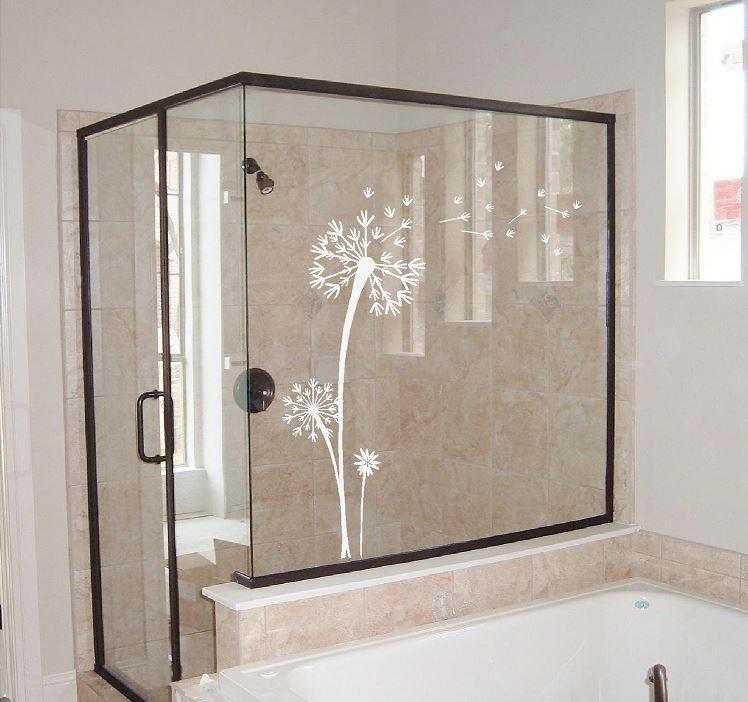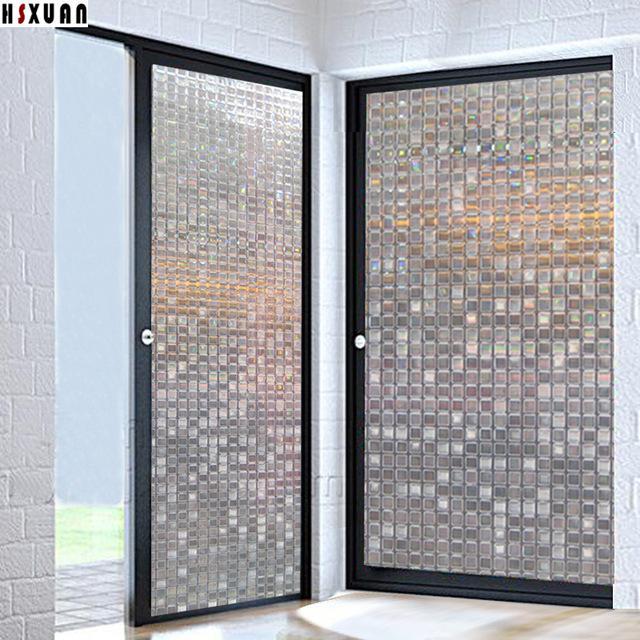The first image is the image on the left, the second image is the image on the right. Considering the images on both sides, is "An image shows a black framed sliding door unit with a narrower middle mirrored section, behind a plush rug and a potted plant." valid? Answer yes or no. No. The first image is the image on the left, the second image is the image on the right. Assess this claim about the two images: "Both images contain an object with a plant design on it.". Correct or not? Answer yes or no. No. 